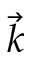Convert formula to latex. <formula><loc_0><loc_0><loc_500><loc_500>\vec { k }</formula> 